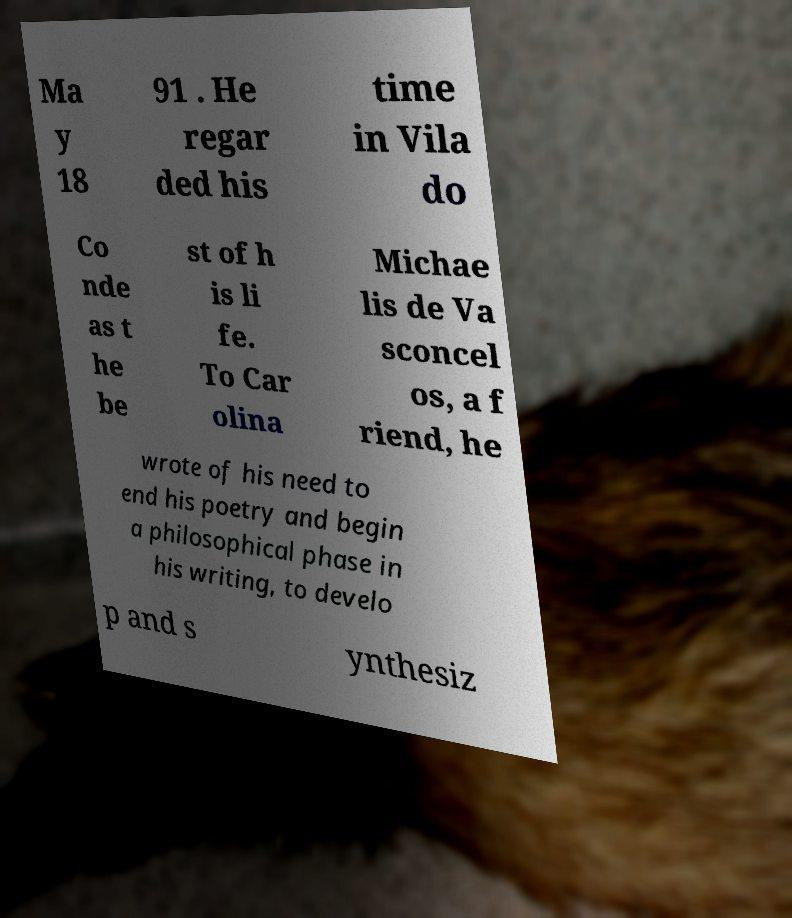Can you read and provide the text displayed in the image?This photo seems to have some interesting text. Can you extract and type it out for me? Ma y 18 91 . He regar ded his time in Vila do Co nde as t he be st of h is li fe. To Car olina Michae lis de Va sconcel os, a f riend, he wrote of his need to end his poetry and begin a philosophical phase in his writing, to develo p and s ynthesiz 